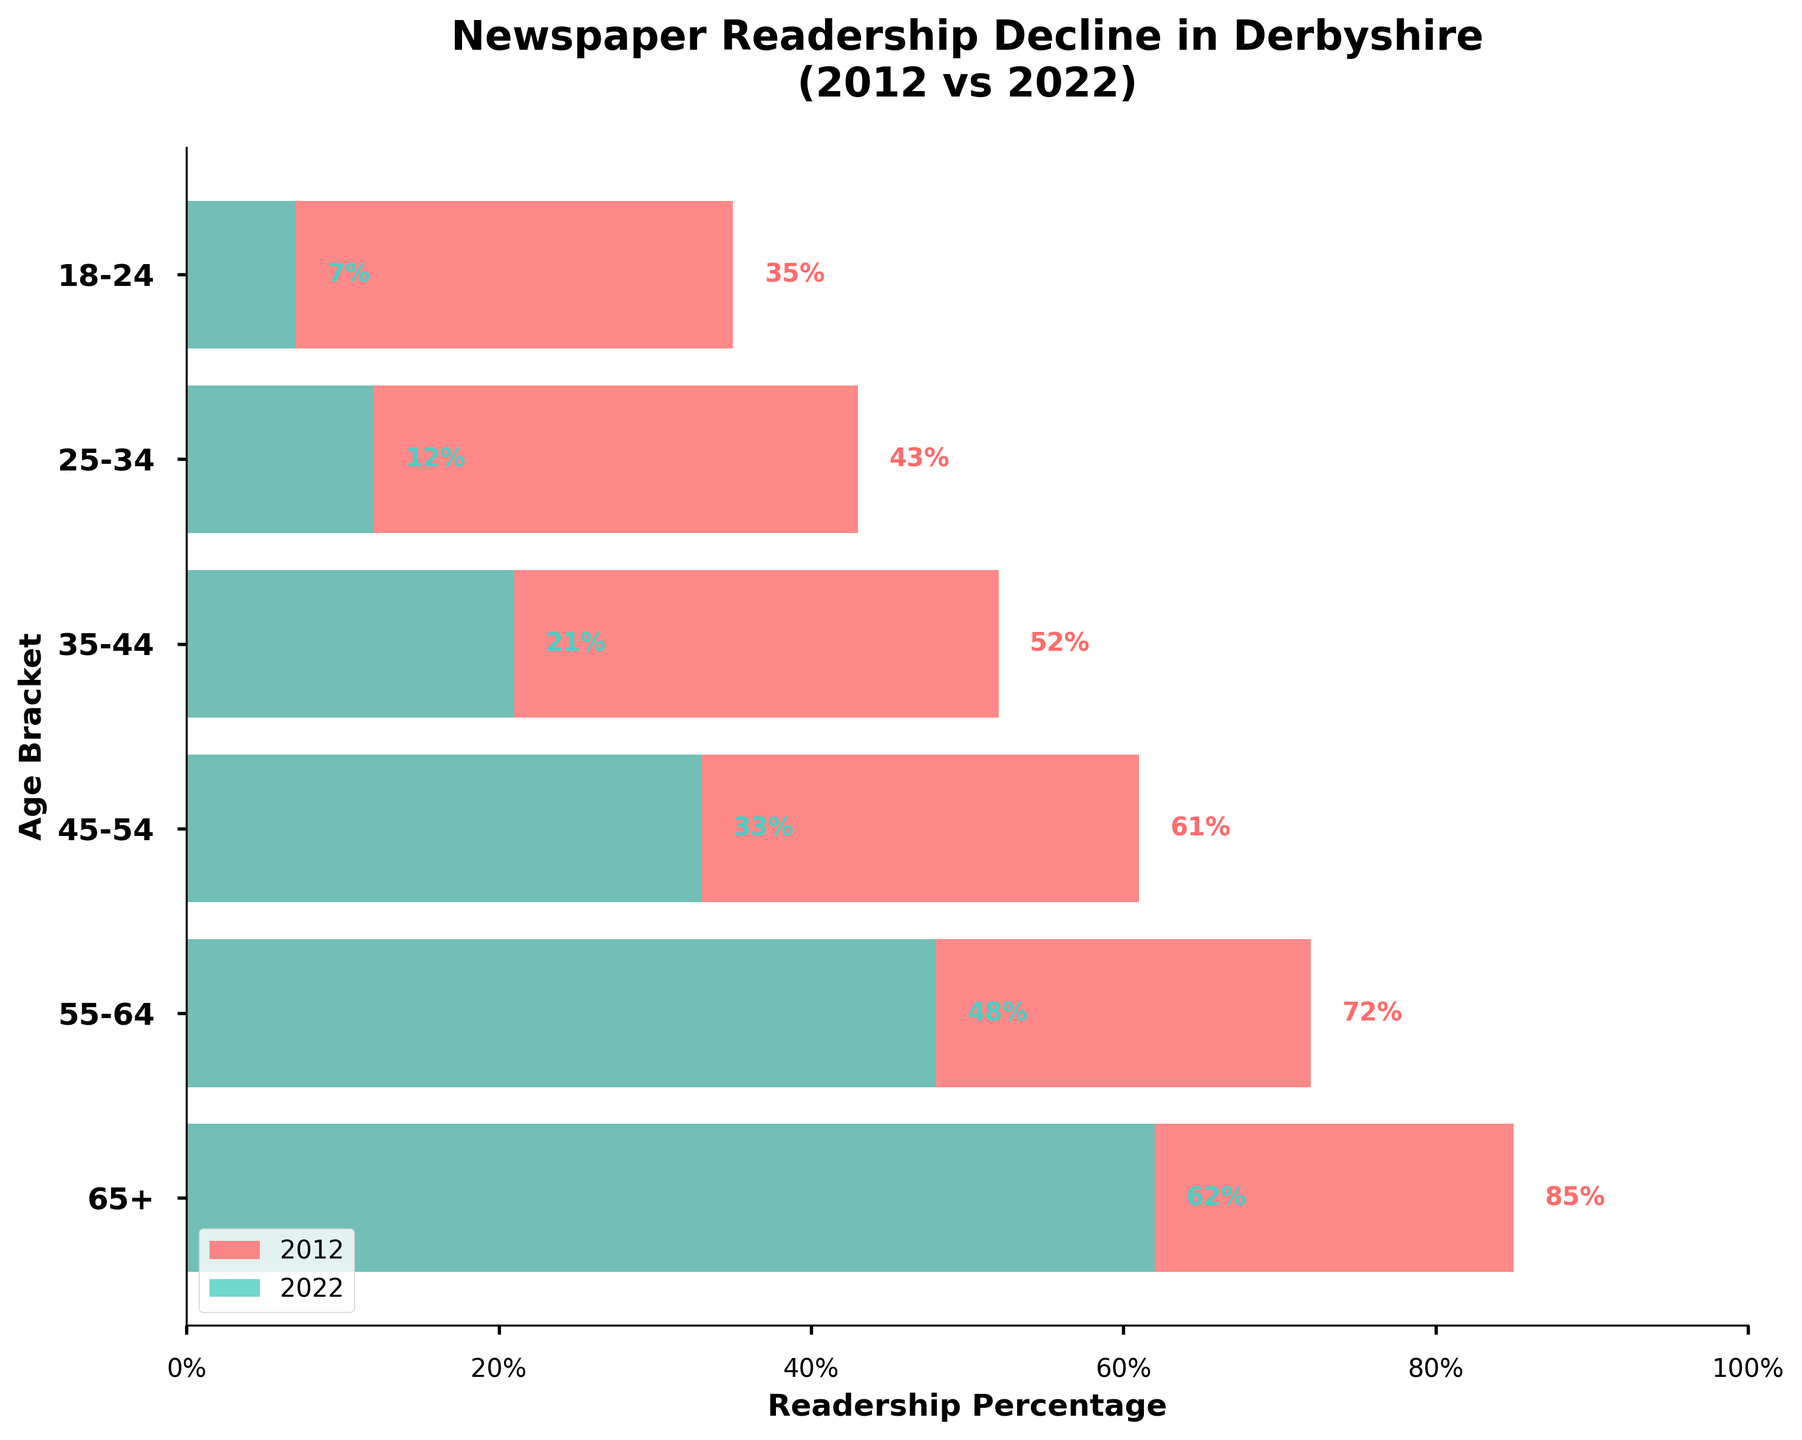What is the title of the chart? The title is displayed prominently at the top of the chart.
Answer: Newspaper Readership Decline in Derbyshire (2012 vs 2022) What are the age brackets represented on the y-axis? The y-axis lists each age bracket from top to bottom in bold font.
Answer: 65+, 55-64, 45-54, 35-44, 25-34, 18-24 Which age bracket had the highest readership in 2012? By comparing the lengths of the red bars, which represent 2012 readership, the longest bar points to the age bracket.
Answer: 65+ What is the difference in readership between 2012 and 2022 for the 55-64 age bracket? Look at the bar lengths for 55-64 and subtract the 2022 value (48%) from the 2012 value (72%).
Answer: 24% Which age bracket showed the lowest readership in 2022? By comparing the lengths of the green bars, the shortest bar indicates the age bracket.
Answer: 18-24 What is the average readership across all age brackets in 2012? Add all the 2012 readership percentages and divide by the number of age brackets (6). (85% + 72% + 61% + 52% + 43% + 35% = 348%, then 348% / 6).
Answer: 58% How much did readership decline for the 18-24 age group from 2012 to 2022? Look at the difference between the 2012 value (35%) and the 2022 value (7%).
Answer: 28% Which age bracket had the second largest decline in readership from 2012 to 2022? Calculate the decline for each age bracket and compare: 
(65+ : 23%, 55-64 : 24%, 45-54 : 28%, 35-44 : 31%, 25-34 : 31%, 18-24 : 28%). The second largest decline is 28% for both 45-54 and 18-24.
Answer: 45-54 Which two age brackets had the largest difference in readership between 2012 and 2022? Identify the age brackets with the largest and smallest values in 2012 and 2022, then find their differences. (65+ vs 18-24: 85% - 35% = 50% in 2012, 62% - 7% = 55% in 2022)
Answer: 65+ and 18-24 